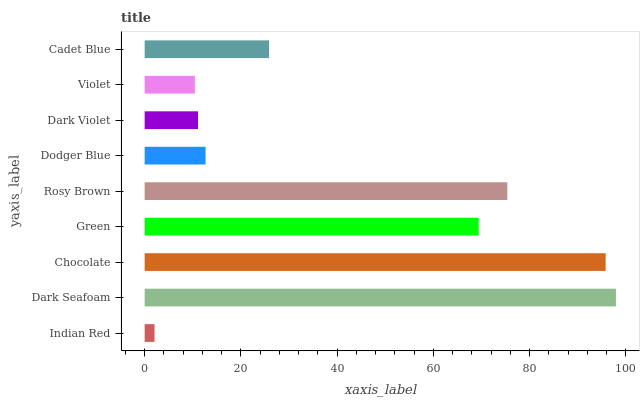Is Indian Red the minimum?
Answer yes or no. Yes. Is Dark Seafoam the maximum?
Answer yes or no. Yes. Is Chocolate the minimum?
Answer yes or no. No. Is Chocolate the maximum?
Answer yes or no. No. Is Dark Seafoam greater than Chocolate?
Answer yes or no. Yes. Is Chocolate less than Dark Seafoam?
Answer yes or no. Yes. Is Chocolate greater than Dark Seafoam?
Answer yes or no. No. Is Dark Seafoam less than Chocolate?
Answer yes or no. No. Is Cadet Blue the high median?
Answer yes or no. Yes. Is Cadet Blue the low median?
Answer yes or no. Yes. Is Dark Violet the high median?
Answer yes or no. No. Is Violet the low median?
Answer yes or no. No. 